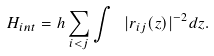<formula> <loc_0><loc_0><loc_500><loc_500>H _ { i n t } = h \sum _ { i < j } \int \ | { r } _ { i j } ( z ) | ^ { - 2 } d z .</formula> 